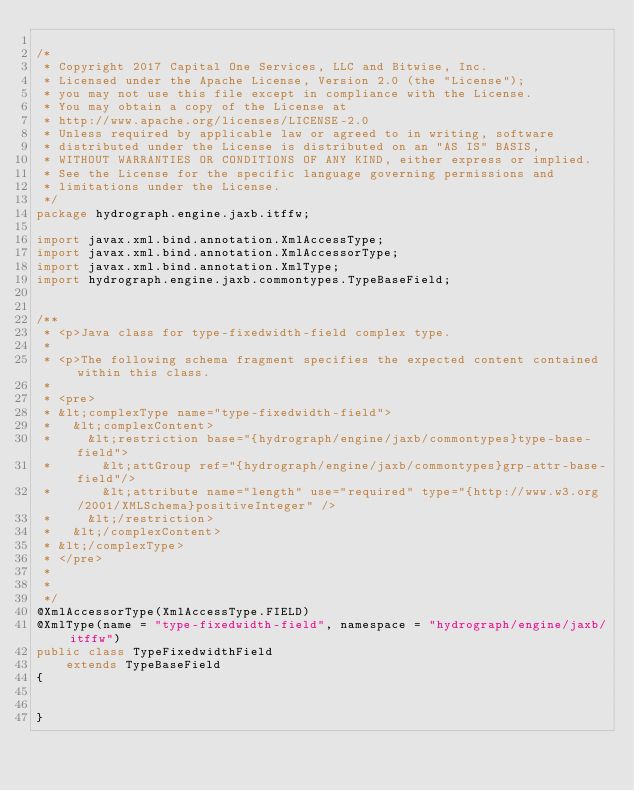<code> <loc_0><loc_0><loc_500><loc_500><_Java_>
/*
 * Copyright 2017 Capital One Services, LLC and Bitwise, Inc.
 * Licensed under the Apache License, Version 2.0 (the "License");
 * you may not use this file except in compliance with the License.
 * You may obtain a copy of the License at
 * http://www.apache.org/licenses/LICENSE-2.0
 * Unless required by applicable law or agreed to in writing, software
 * distributed under the License is distributed on an "AS IS" BASIS,
 * WITHOUT WARRANTIES OR CONDITIONS OF ANY KIND, either express or implied.
 * See the License for the specific language governing permissions and
 * limitations under the License.
 */
package hydrograph.engine.jaxb.itffw;

import javax.xml.bind.annotation.XmlAccessType;
import javax.xml.bind.annotation.XmlAccessorType;
import javax.xml.bind.annotation.XmlType;
import hydrograph.engine.jaxb.commontypes.TypeBaseField;


/**
 * <p>Java class for type-fixedwidth-field complex type.
 * 
 * <p>The following schema fragment specifies the expected content contained within this class.
 * 
 * <pre>
 * &lt;complexType name="type-fixedwidth-field">
 *   &lt;complexContent>
 *     &lt;restriction base="{hydrograph/engine/jaxb/commontypes}type-base-field">
 *       &lt;attGroup ref="{hydrograph/engine/jaxb/commontypes}grp-attr-base-field"/>
 *       &lt;attribute name="length" use="required" type="{http://www.w3.org/2001/XMLSchema}positiveInteger" />
 *     &lt;/restriction>
 *   &lt;/complexContent>
 * &lt;/complexType>
 * </pre>
 * 
 * 
 */
@XmlAccessorType(XmlAccessType.FIELD)
@XmlType(name = "type-fixedwidth-field", namespace = "hydrograph/engine/jaxb/itffw")
public class TypeFixedwidthField
    extends TypeBaseField
{


}
</code> 